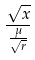<formula> <loc_0><loc_0><loc_500><loc_500>\frac { \sqrt { x } } { \frac { \mu } { \sqrt { r } } }</formula> 